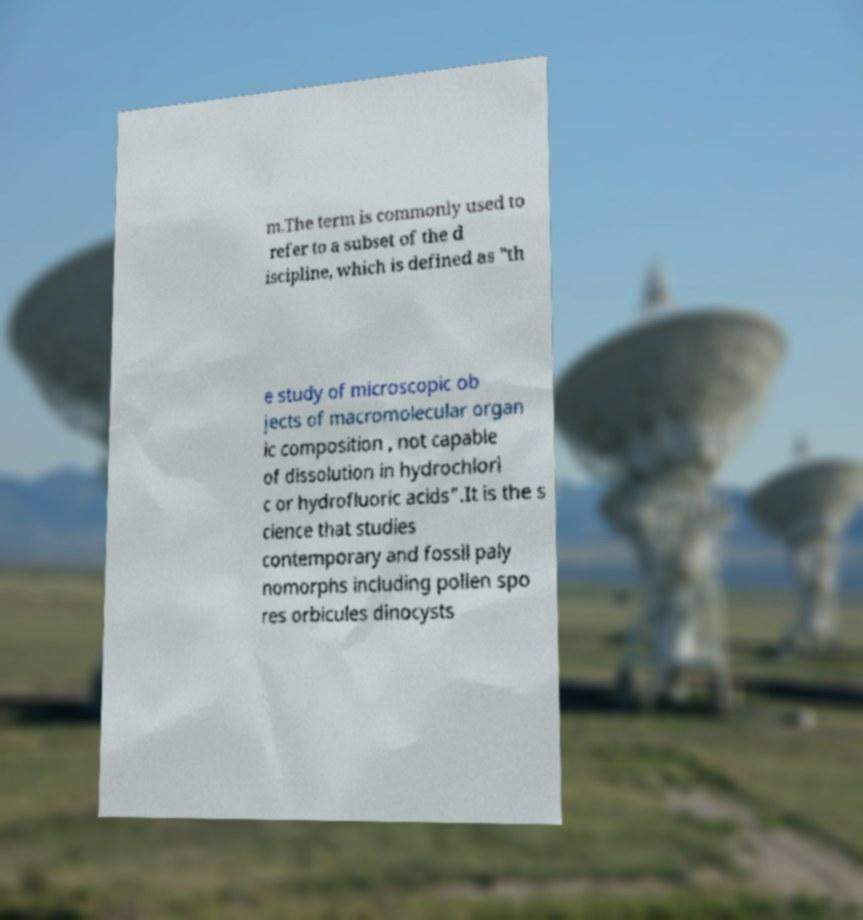Please read and relay the text visible in this image. What does it say? m.The term is commonly used to refer to a subset of the d iscipline, which is defined as "th e study of microscopic ob jects of macromolecular organ ic composition , not capable of dissolution in hydrochlori c or hydrofluoric acids".It is the s cience that studies contemporary and fossil paly nomorphs including pollen spo res orbicules dinocysts 